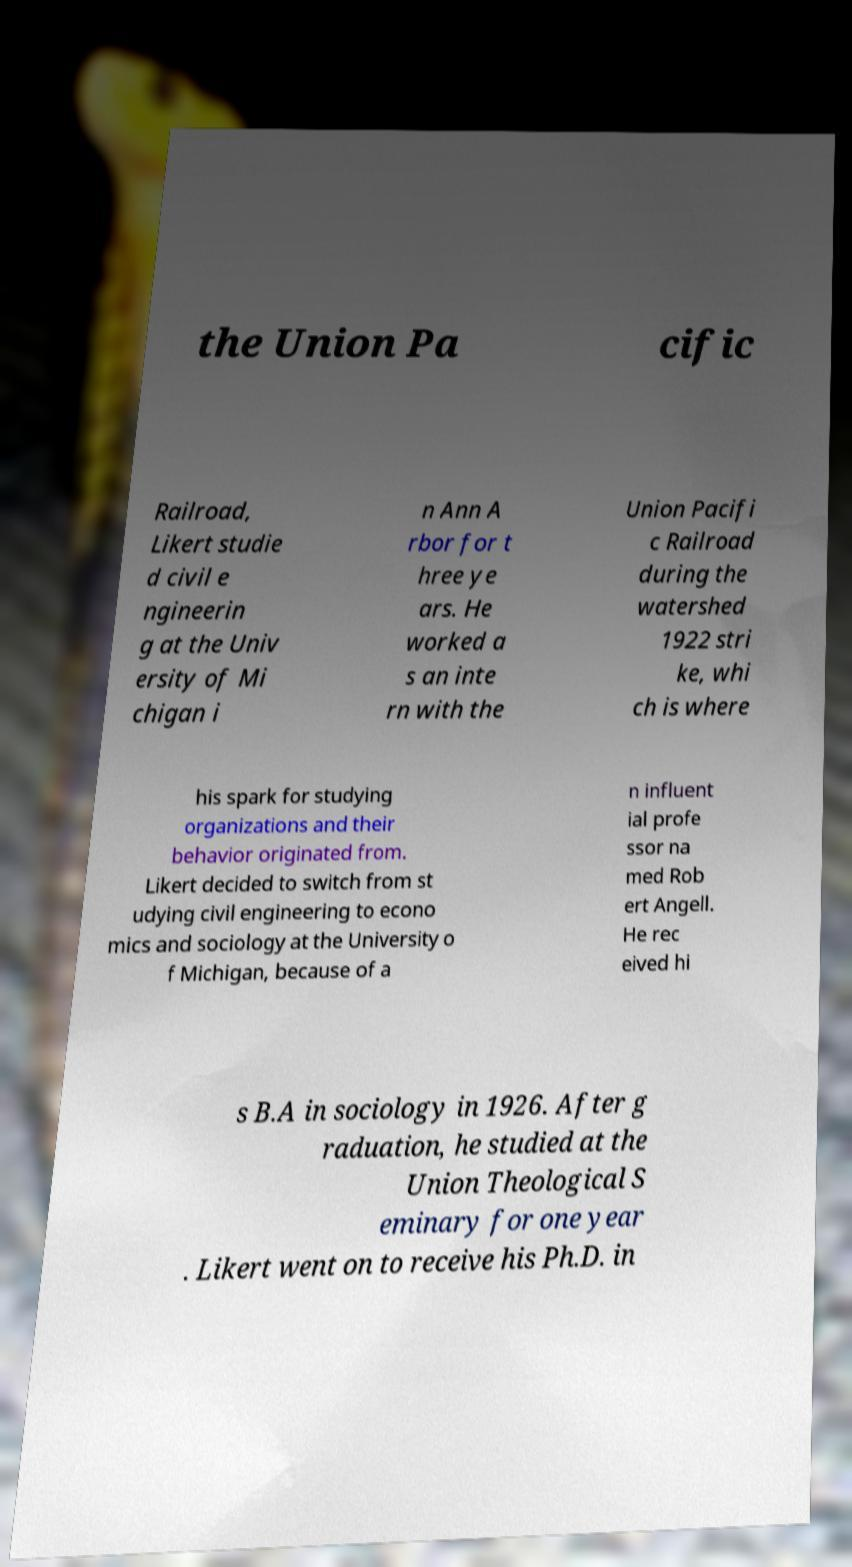Please identify and transcribe the text found in this image. the Union Pa cific Railroad, Likert studie d civil e ngineerin g at the Univ ersity of Mi chigan i n Ann A rbor for t hree ye ars. He worked a s an inte rn with the Union Pacifi c Railroad during the watershed 1922 stri ke, whi ch is where his spark for studying organizations and their behavior originated from. Likert decided to switch from st udying civil engineering to econo mics and sociology at the University o f Michigan, because of a n influent ial profe ssor na med Rob ert Angell. He rec eived hi s B.A in sociology in 1926. After g raduation, he studied at the Union Theological S eminary for one year . Likert went on to receive his Ph.D. in 